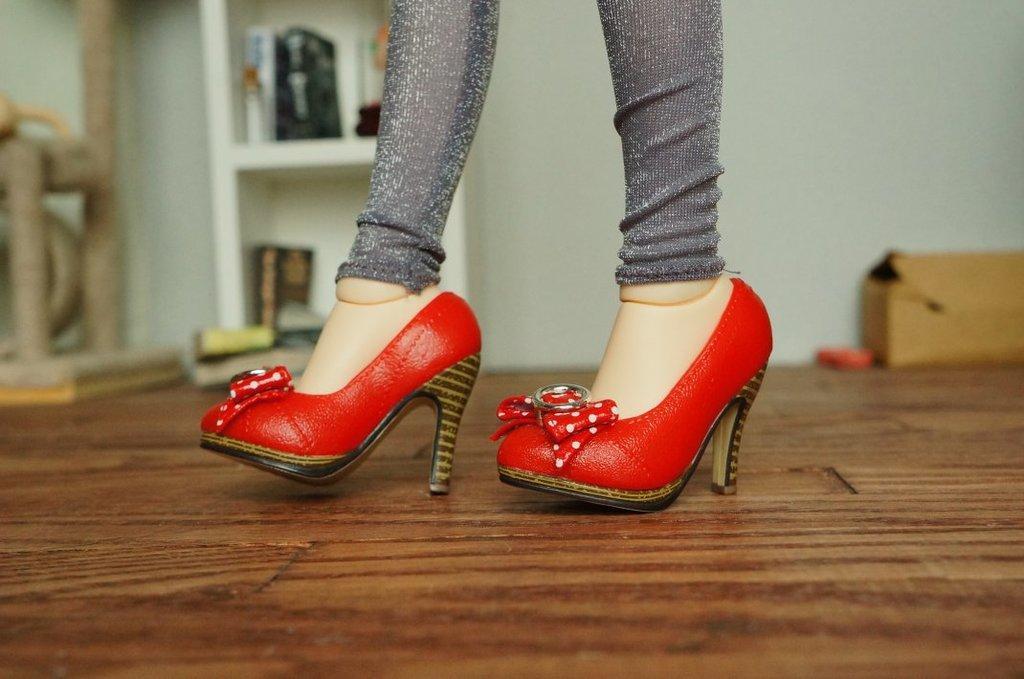In one or two sentences, can you explain what this image depicts? In this picture we can see women legs and red color shoes. 